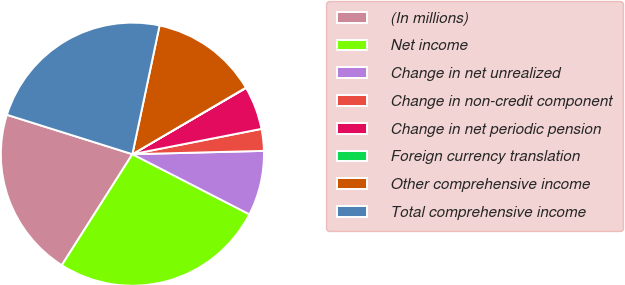<chart> <loc_0><loc_0><loc_500><loc_500><pie_chart><fcel>(In millions)<fcel>Net income<fcel>Change in net unrealized<fcel>Change in non-credit component<fcel>Change in net periodic pension<fcel>Foreign currency translation<fcel>Other comprehensive income<fcel>Total comprehensive income<nl><fcel>20.83%<fcel>26.46%<fcel>7.96%<fcel>2.68%<fcel>5.32%<fcel>0.04%<fcel>13.25%<fcel>23.47%<nl></chart> 